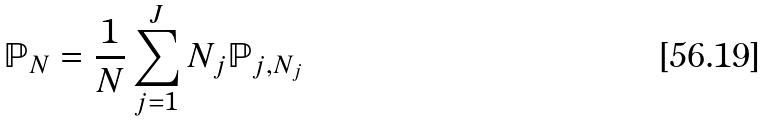Convert formula to latex. <formula><loc_0><loc_0><loc_500><loc_500>\mathbb { P } _ { N } = \frac { 1 } { N } \sum _ { j = 1 } ^ { J } N _ { j } \mathbb { P } _ { j , N _ { j } }</formula> 